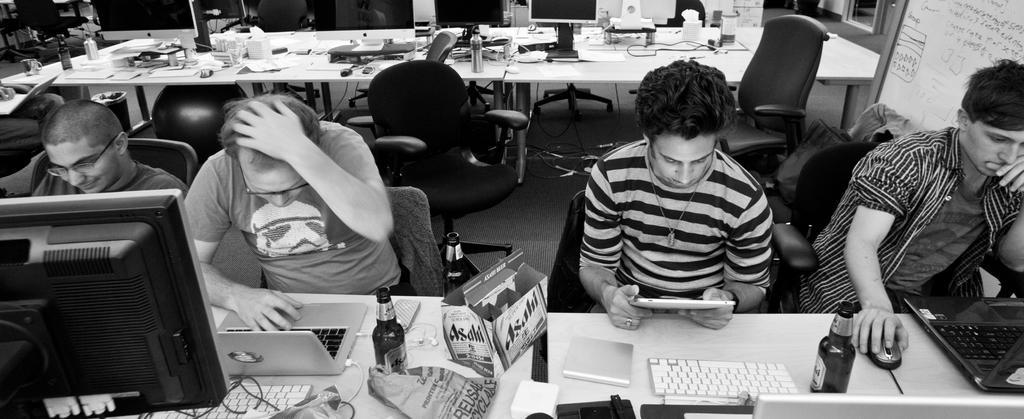In one or two sentences, can you explain what this image depicts? In this image we can see a few people, two of them working on laptops, a person is holding an electronic gadget, in front of them there is a table, on the table, there are laptops, keyboards, mouse, bottle, box, there is another table, on that we can see bottles, and some other objects, there are chairs, dustbin, a board with some text on it, also we can see the wall, and windows. 